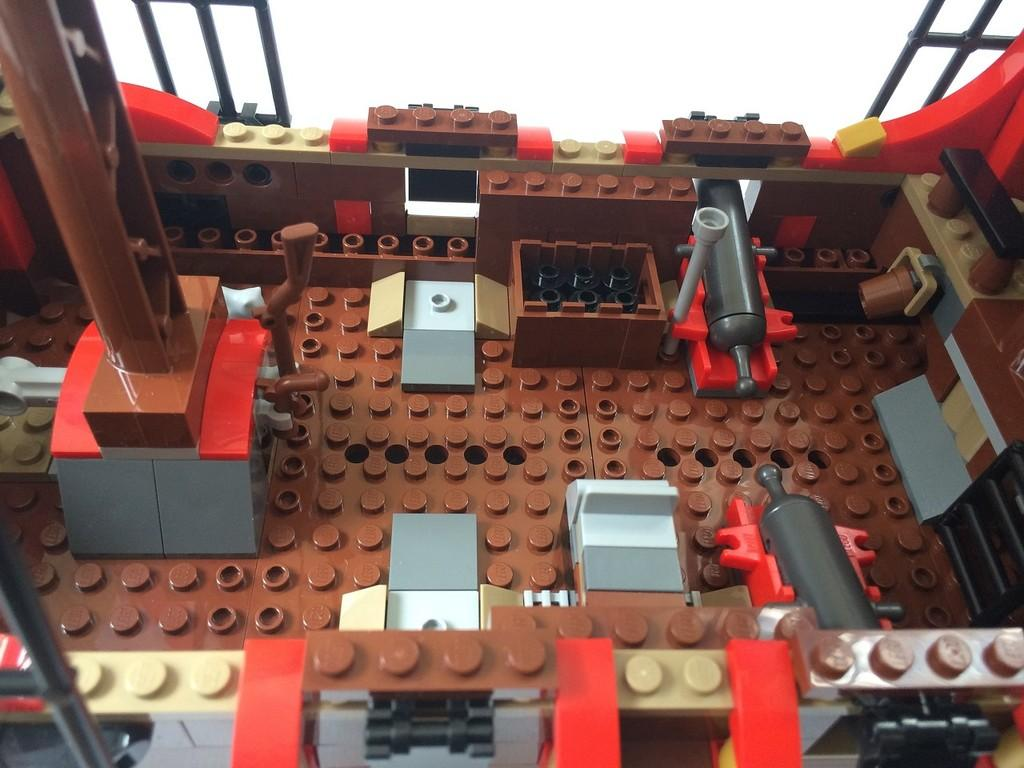What types of items can be seen in the image? There are toys and other objects in the image. What color is the background of the image? The background of the image is white in color. What sense is being used by the toys in the image? Toys do not have senses, as they are inanimate objects. 